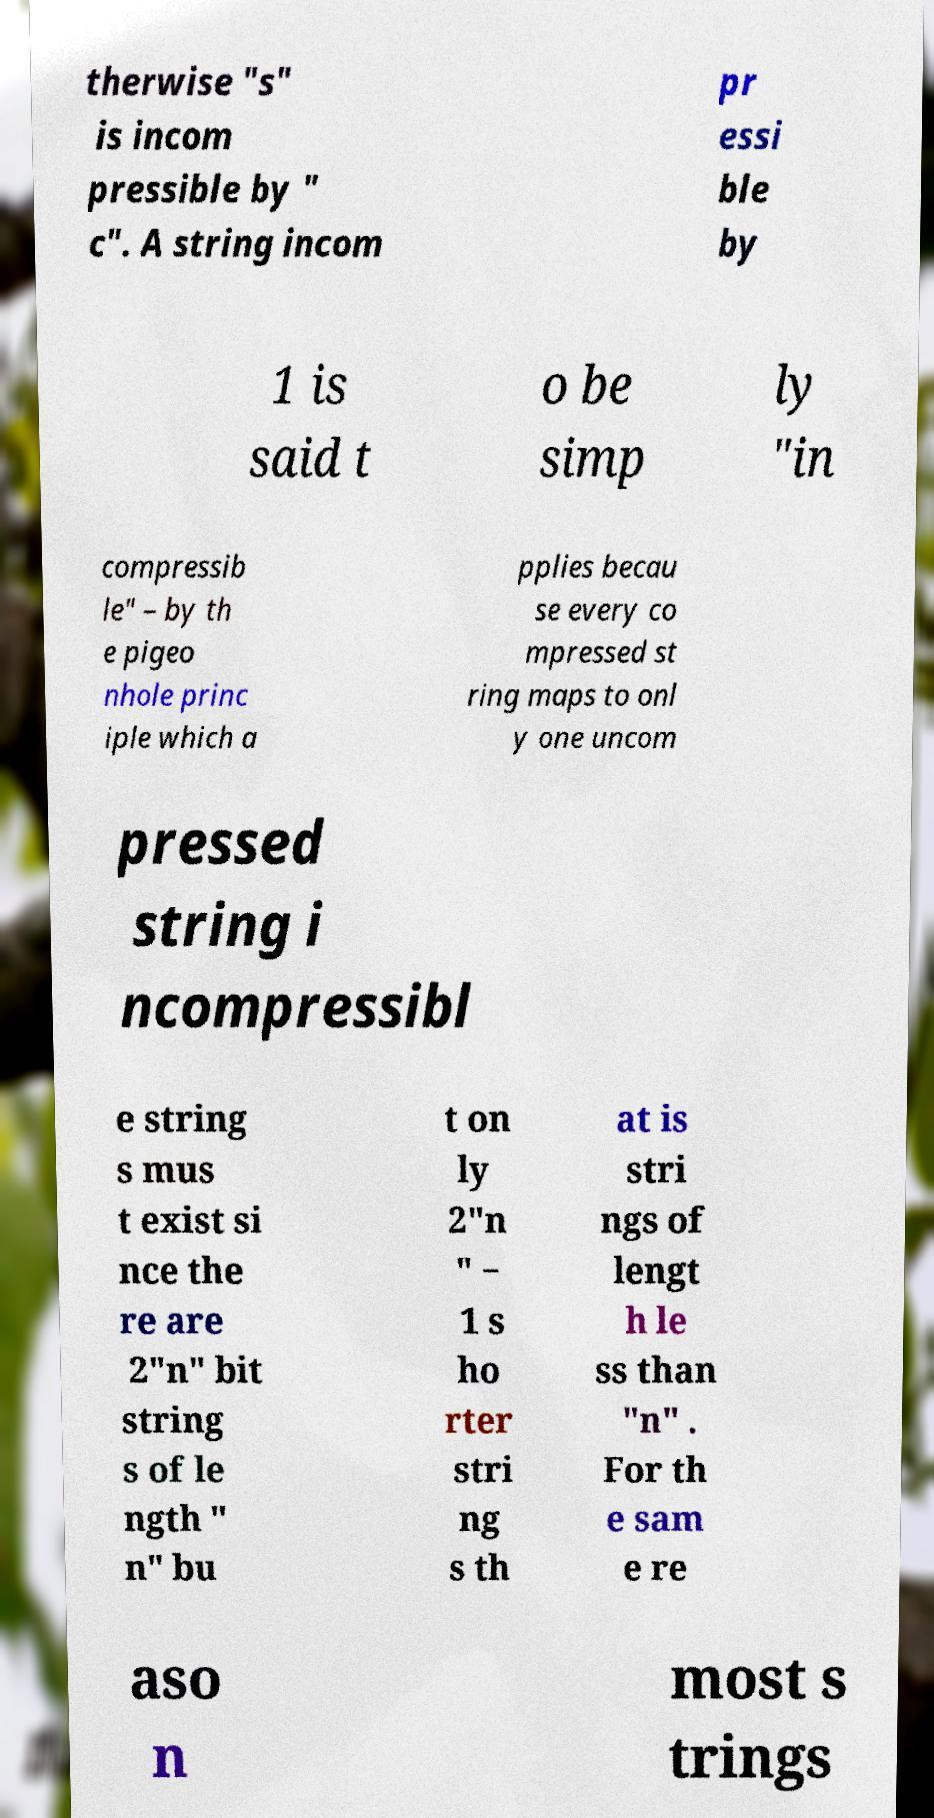Could you extract and type out the text from this image? therwise "s" is incom pressible by " c". A string incom pr essi ble by 1 is said t o be simp ly "in compressib le" – by th e pigeo nhole princ iple which a pplies becau se every co mpressed st ring maps to onl y one uncom pressed string i ncompressibl e string s mus t exist si nce the re are 2"n" bit string s of le ngth " n" bu t on ly 2"n " − 1 s ho rter stri ng s th at is stri ngs of lengt h le ss than "n" . For th e sam e re aso n most s trings 